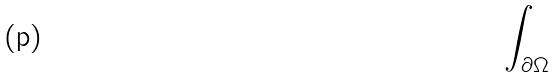<formula> <loc_0><loc_0><loc_500><loc_500>\int _ { \partial \Omega }</formula> 